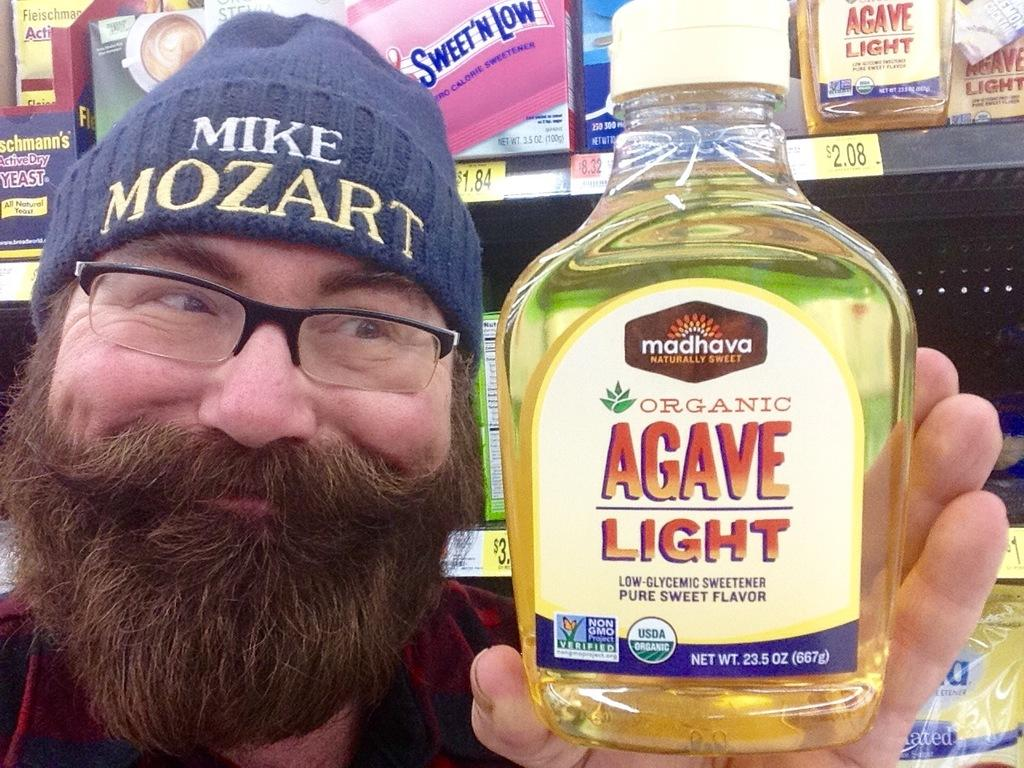What is the main subject of the image? There is a person in the image. What is the person holding in the image? The person is holding a bottle. Can you describe the background of the image? There is a metal rack with objects in the background of the image. What type of sack is the fireman carrying in the image? There is no fireman or sack present in the image. How many horses can be seen in the image? There are no horses present in the image. 